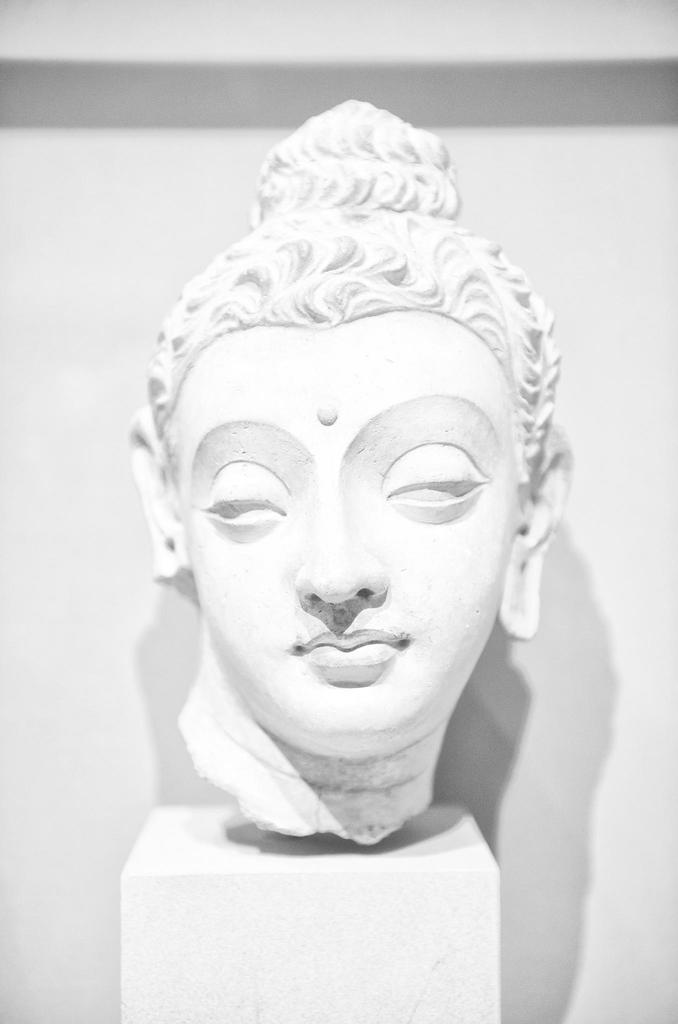Describe this image in one or two sentences. In this picture there is a sculpture which is in white color. 